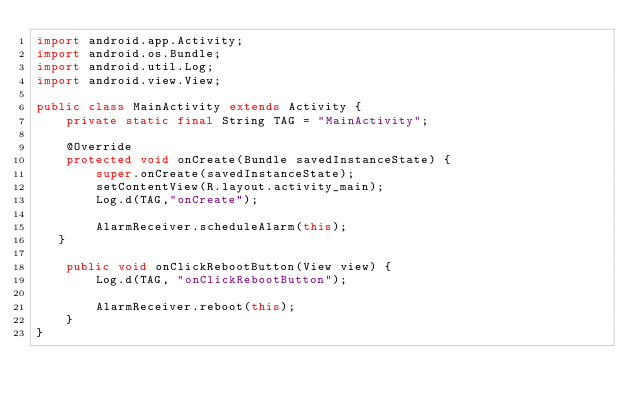<code> <loc_0><loc_0><loc_500><loc_500><_Java_>import android.app.Activity;
import android.os.Bundle;
import android.util.Log;
import android.view.View;

public class MainActivity extends Activity {
    private static final String TAG = "MainActivity";

    @Override
    protected void onCreate(Bundle savedInstanceState) {
        super.onCreate(savedInstanceState);
        setContentView(R.layout.activity_main);
        Log.d(TAG,"onCreate");

        AlarmReceiver.scheduleAlarm(this);
   }

    public void onClickRebootButton(View view) {
        Log.d(TAG, "onClickRebootButton");

        AlarmReceiver.reboot(this);
    }
}
</code> 